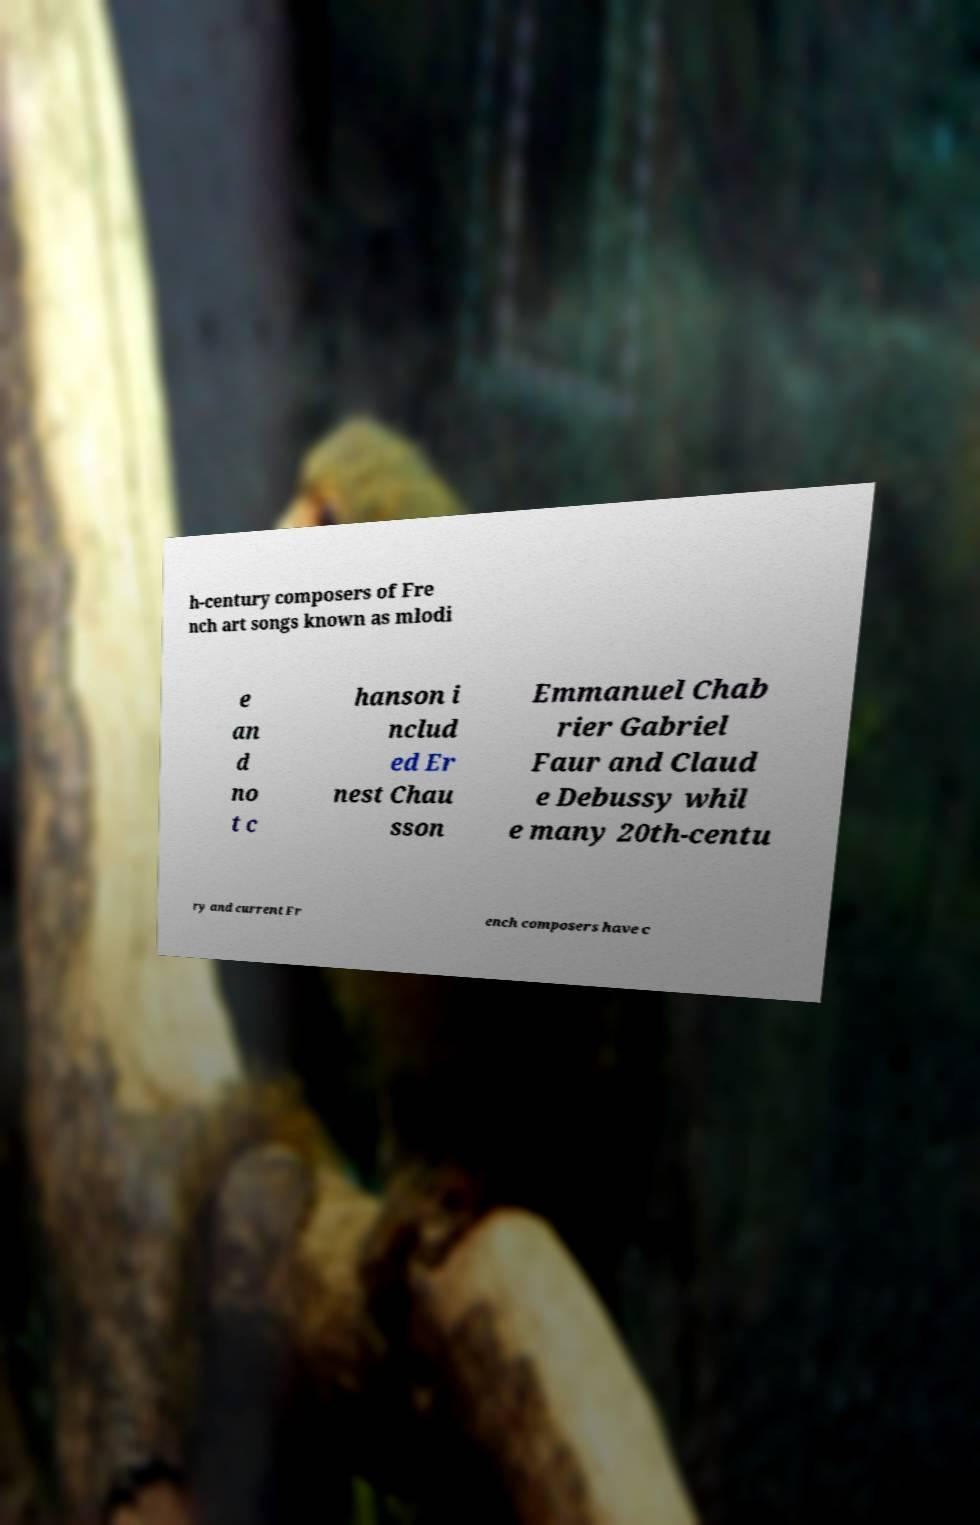For documentation purposes, I need the text within this image transcribed. Could you provide that? h-century composers of Fre nch art songs known as mlodi e an d no t c hanson i nclud ed Er nest Chau sson Emmanuel Chab rier Gabriel Faur and Claud e Debussy whil e many 20th-centu ry and current Fr ench composers have c 